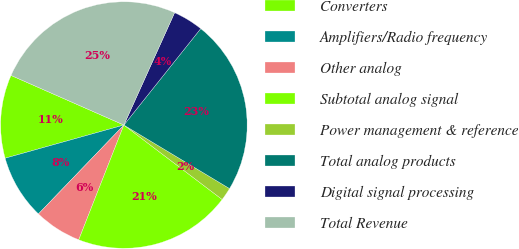Convert chart to OTSL. <chart><loc_0><loc_0><loc_500><loc_500><pie_chart><fcel>Converters<fcel>Amplifiers/Radio frequency<fcel>Other analog<fcel>Subtotal analog signal<fcel>Power management & reference<fcel>Total analog products<fcel>Digital signal processing<fcel>Total Revenue<nl><fcel>10.93%<fcel>8.48%<fcel>6.22%<fcel>20.65%<fcel>1.7%<fcel>22.91%<fcel>3.96%<fcel>25.16%<nl></chart> 